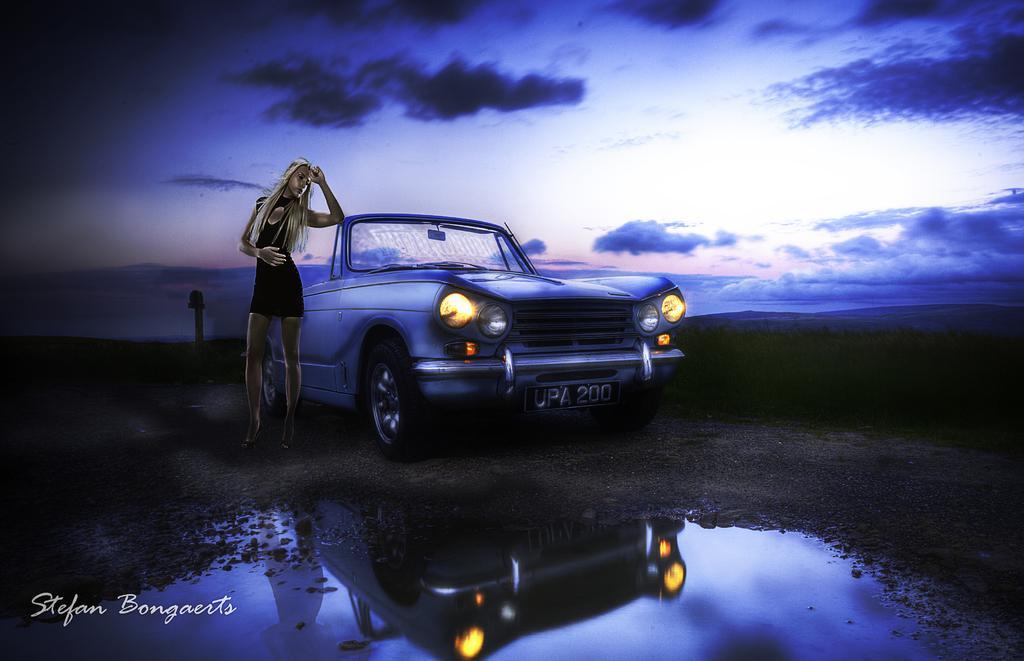Can you describe this image briefly? This is an animated image. In the center we can see a woman standing on the ground and we can see a car parked on the ground. In the foreground we can see the water. In the background we can see the sky with the clouds and we can see some other objects. In the bottom left corner there is a watermark on the image. 